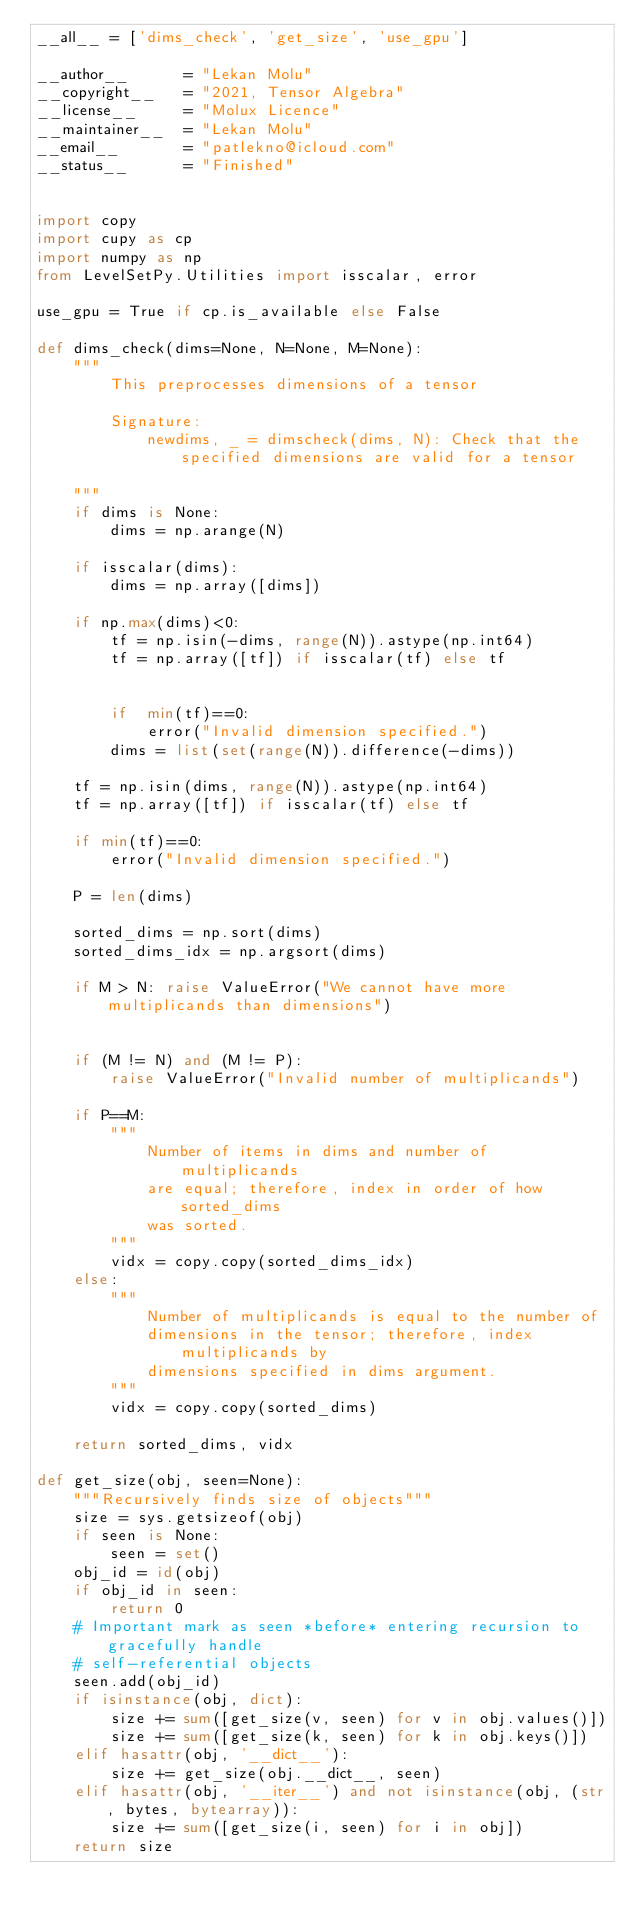<code> <loc_0><loc_0><loc_500><loc_500><_Python_>__all__ = ['dims_check', 'get_size', 'use_gpu']

__author__ 		= "Lekan Molu"
__copyright__ 	= "2021, Tensor Algebra"
__license__ 	= "Molux Licence"
__maintainer__ 	= "Lekan Molu"
__email__ 		= "patlekno@icloud.com"
__status__ 		= "Finished"


import copy
import cupy as cp
import numpy as np
from LevelSetPy.Utilities import isscalar, error

use_gpu = True if cp.is_available else False

def dims_check(dims=None, N=None, M=None):
    """
        This preprocesses dimensions of a tensor

        Signature:
            newdims, _ = dimscheck(dims, N): Check that the specified dimensions are valid for a tensor

    """
    if dims is None:
        dims = np.arange(N)

    if isscalar(dims):
        dims = np.array([dims])

    if np.max(dims)<0:
        tf = np.isin(-dims, range(N)).astype(np.int64)
        tf = np.array([tf]) if isscalar(tf) else tf


        if  min(tf)==0:
            error("Invalid dimension specified.")
        dims = list(set(range(N)).difference(-dims))

    tf = np.isin(dims, range(N)).astype(np.int64)
    tf = np.array([tf]) if isscalar(tf) else tf

    if min(tf)==0:
        error("Invalid dimension specified.")

    P = len(dims)

    sorted_dims = np.sort(dims)
    sorted_dims_idx = np.argsort(dims)

    if M > N: raise ValueError("We cannot have more multiplicands than dimensions")


    if (M != N) and (M != P):
        raise ValueError("Invalid number of multiplicands")

    if P==M:
        """
            Number of items in dims and number of multiplicands
            are equal; therefore, index in order of how sorted_dims
            was sorted.
        """
        vidx = copy.copy(sorted_dims_idx)
    else:
        """
            Number of multiplicands is equal to the number of
            dimensions in the tensor; therefore, index multiplicands by
            dimensions specified in dims argument.
        """
        vidx = copy.copy(sorted_dims)

    return sorted_dims, vidx

def get_size(obj, seen=None):
    """Recursively finds size of objects"""
    size = sys.getsizeof(obj)
    if seen is None:
        seen = set()
    obj_id = id(obj)
    if obj_id in seen:
        return 0
    # Important mark as seen *before* entering recursion to gracefully handle
    # self-referential objects
    seen.add(obj_id)
    if isinstance(obj, dict):
        size += sum([get_size(v, seen) for v in obj.values()])
        size += sum([get_size(k, seen) for k in obj.keys()])
    elif hasattr(obj, '__dict__'):
        size += get_size(obj.__dict__, seen)
    elif hasattr(obj, '__iter__') and not isinstance(obj, (str, bytes, bytearray)):
        size += sum([get_size(i, seen) for i in obj])
    return size
</code> 